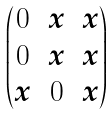Convert formula to latex. <formula><loc_0><loc_0><loc_500><loc_500>\begin{pmatrix} 0 & x & x \\ 0 & x & x \\ x & 0 & x \\ \end{pmatrix}</formula> 